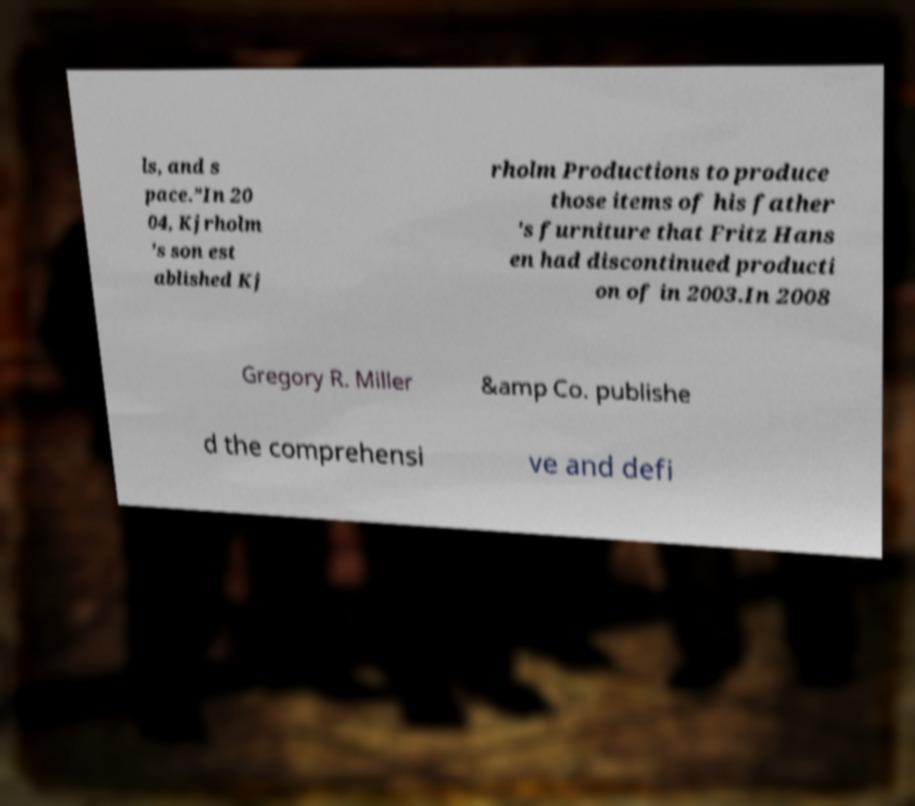Can you read and provide the text displayed in the image?This photo seems to have some interesting text. Can you extract and type it out for me? ls, and s pace.”In 20 04, Kjrholm 's son est ablished Kj rholm Productions to produce those items of his father 's furniture that Fritz Hans en had discontinued producti on of in 2003.In 2008 Gregory R. Miller &amp Co. publishe d the comprehensi ve and defi 